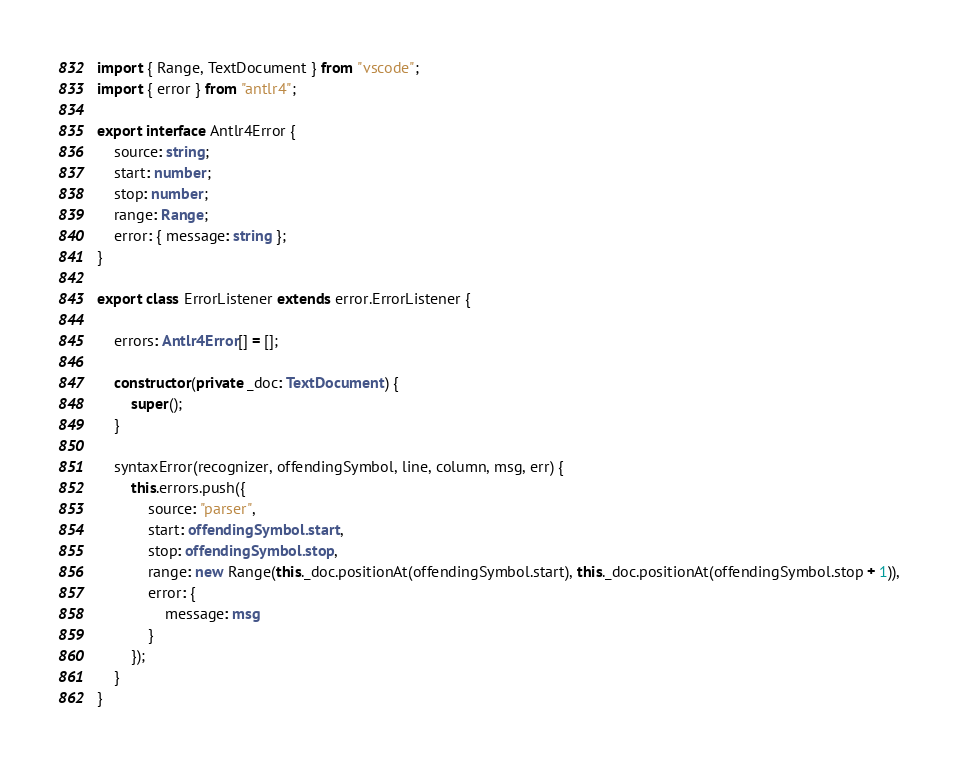<code> <loc_0><loc_0><loc_500><loc_500><_TypeScript_>import { Range, TextDocument } from "vscode";
import { error } from "antlr4";

export interface Antlr4Error {
    source: string;
    start: number;
    stop: number;
    range: Range;
    error: { message: string };
}

export class ErrorListener extends error.ErrorListener {

    errors: Antlr4Error[] = [];

    constructor(private _doc: TextDocument) {
        super();
    }

    syntaxError(recognizer, offendingSymbol, line, column, msg, err) {
        this.errors.push({
            source: "parser",
            start: offendingSymbol.start,
            stop: offendingSymbol.stop,
            range: new Range(this._doc.positionAt(offendingSymbol.start), this._doc.positionAt(offendingSymbol.stop + 1)),
            error: {
                message: msg
            }
        });
    }
}
</code> 